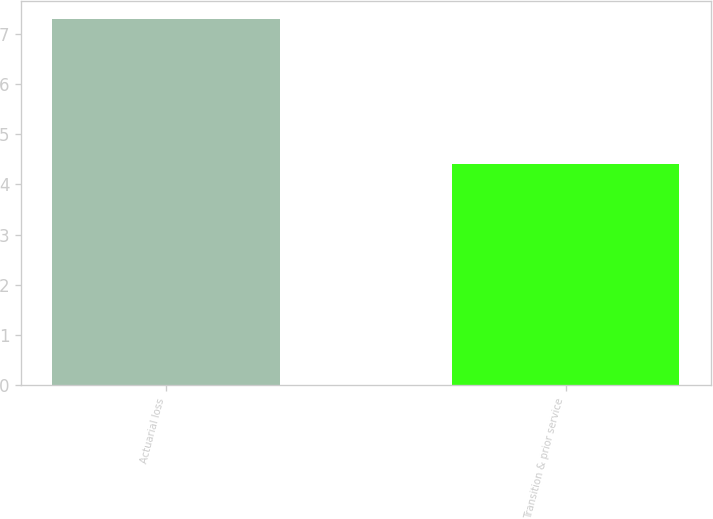Convert chart to OTSL. <chart><loc_0><loc_0><loc_500><loc_500><bar_chart><fcel>Actuarial loss<fcel>Transition & prior service<nl><fcel>7.3<fcel>4.4<nl></chart> 